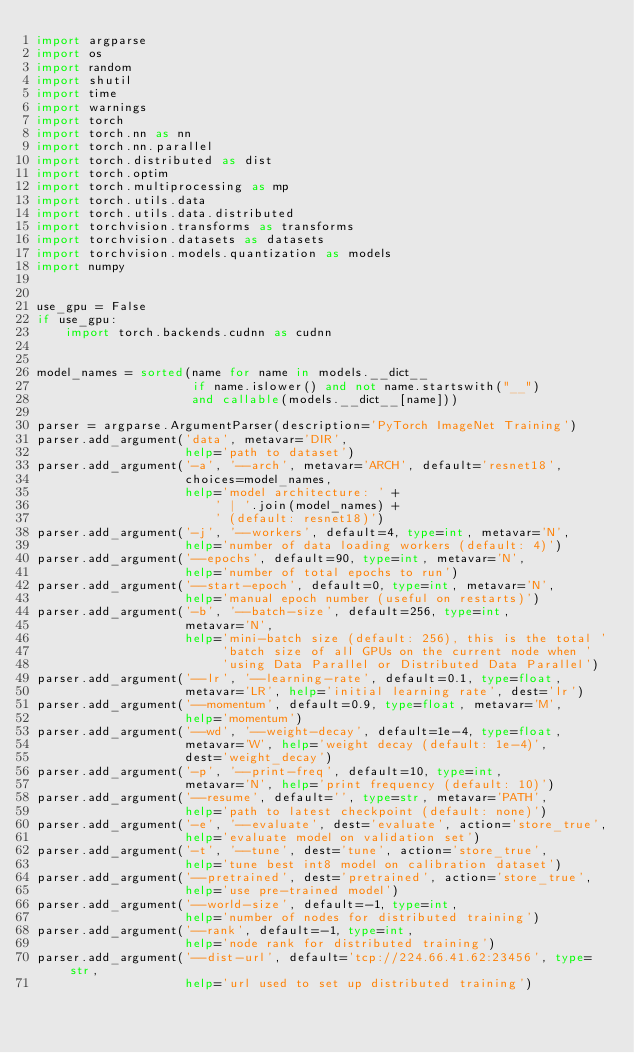Convert code to text. <code><loc_0><loc_0><loc_500><loc_500><_Python_>import argparse
import os
import random
import shutil
import time
import warnings
import torch
import torch.nn as nn
import torch.nn.parallel
import torch.distributed as dist
import torch.optim
import torch.multiprocessing as mp
import torch.utils.data
import torch.utils.data.distributed
import torchvision.transforms as transforms
import torchvision.datasets as datasets
import torchvision.models.quantization as models
import numpy


use_gpu = False
if use_gpu:
    import torch.backends.cudnn as cudnn


model_names = sorted(name for name in models.__dict__
                     if name.islower() and not name.startswith("__")
                     and callable(models.__dict__[name]))

parser = argparse.ArgumentParser(description='PyTorch ImageNet Training')
parser.add_argument('data', metavar='DIR',
                    help='path to dataset')
parser.add_argument('-a', '--arch', metavar='ARCH', default='resnet18',
                    choices=model_names,
                    help='model architecture: ' +
                        ' | '.join(model_names) +
                        ' (default: resnet18)')
parser.add_argument('-j', '--workers', default=4, type=int, metavar='N',
                    help='number of data loading workers (default: 4)')
parser.add_argument('--epochs', default=90, type=int, metavar='N',
                    help='number of total epochs to run')
parser.add_argument('--start-epoch', default=0, type=int, metavar='N',
                    help='manual epoch number (useful on restarts)')
parser.add_argument('-b', '--batch-size', default=256, type=int,
                    metavar='N',
                    help='mini-batch size (default: 256), this is the total '
                         'batch size of all GPUs on the current node when '
                         'using Data Parallel or Distributed Data Parallel')
parser.add_argument('--lr', '--learning-rate', default=0.1, type=float,
                    metavar='LR', help='initial learning rate', dest='lr')
parser.add_argument('--momentum', default=0.9, type=float, metavar='M',
                    help='momentum')
parser.add_argument('--wd', '--weight-decay', default=1e-4, type=float,
                    metavar='W', help='weight decay (default: 1e-4)',
                    dest='weight_decay')
parser.add_argument('-p', '--print-freq', default=10, type=int,
                    metavar='N', help='print frequency (default: 10)')
parser.add_argument('--resume', default='', type=str, metavar='PATH',
                    help='path to latest checkpoint (default: none)')
parser.add_argument('-e', '--evaluate', dest='evaluate', action='store_true',
                    help='evaluate model on validation set')
parser.add_argument('-t', '--tune', dest='tune', action='store_true',
                    help='tune best int8 model on calibration dataset')
parser.add_argument('--pretrained', dest='pretrained', action='store_true',
                    help='use pre-trained model')
parser.add_argument('--world-size', default=-1, type=int,
                    help='number of nodes for distributed training')
parser.add_argument('--rank', default=-1, type=int,
                    help='node rank for distributed training')
parser.add_argument('--dist-url', default='tcp://224.66.41.62:23456', type=str,
                    help='url used to set up distributed training')</code> 